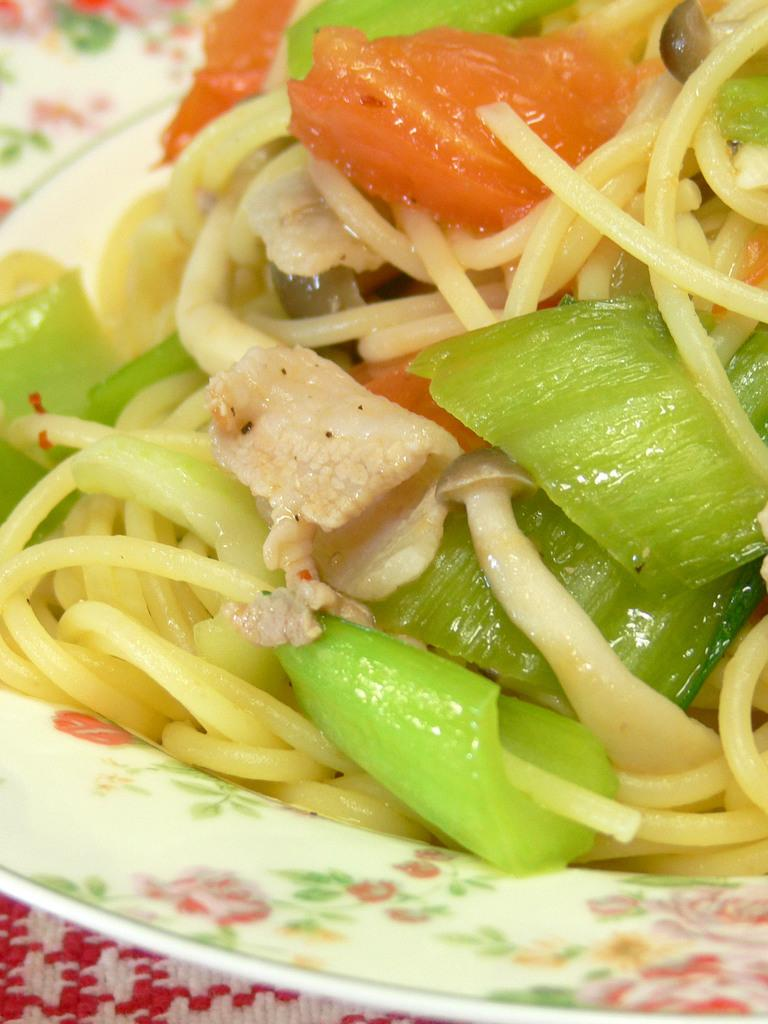What is the main food item on the plate in the image? There is a food item on a plate in the image, but the specific type of food cannot be determined from the provided facts. What other types of food can be seen in the image? There are different vegetables present in the image. What type of knowledge is being shared in the image? There is no indication of knowledge being shared in the image; it primarily features a food item on a plate and different vegetables. 